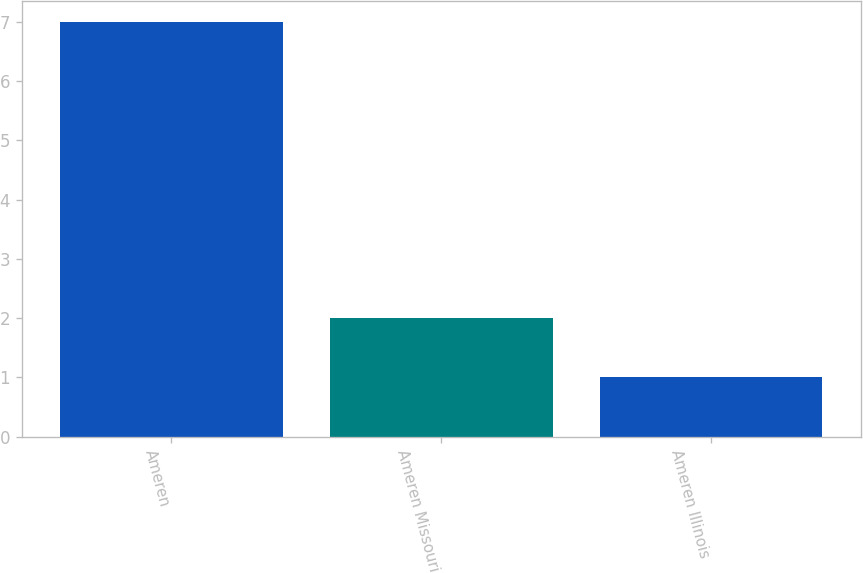Convert chart. <chart><loc_0><loc_0><loc_500><loc_500><bar_chart><fcel>Ameren<fcel>Ameren Missouri<fcel>Ameren Illinois<nl><fcel>7<fcel>2<fcel>1<nl></chart> 